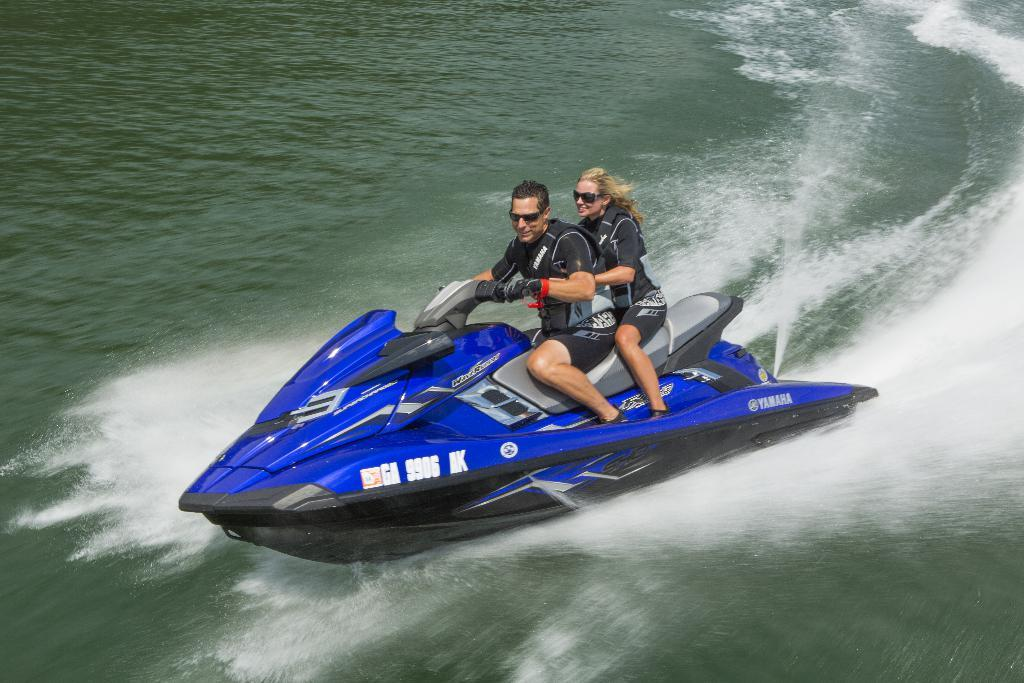How many people are in the image? There are two people in the image. What are the people wearing? The people are wearing clothes and goggles. What expression do the people have? The people are smiling. What are the people sitting on in the image? The people are sitting on a jet ski. Where is the jet ski located? The jet ski is in the water. What type of root can be seen growing near the people in the image? There is no root visible in the image; the people are sitting on a jet ski in the water. 